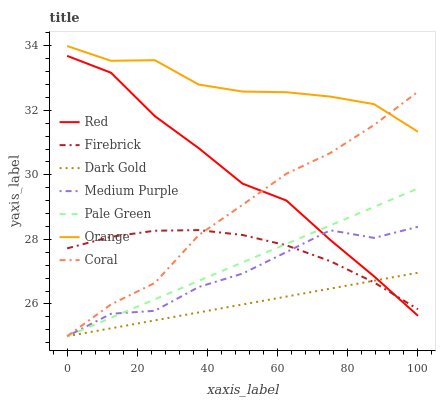Does Dark Gold have the minimum area under the curve?
Answer yes or no. Yes. Does Orange have the maximum area under the curve?
Answer yes or no. Yes. Does Firebrick have the minimum area under the curve?
Answer yes or no. No. Does Firebrick have the maximum area under the curve?
Answer yes or no. No. Is Dark Gold the smoothest?
Answer yes or no. Yes. Is Medium Purple the roughest?
Answer yes or no. Yes. Is Firebrick the smoothest?
Answer yes or no. No. Is Firebrick the roughest?
Answer yes or no. No. Does Firebrick have the lowest value?
Answer yes or no. No. Does Orange have the highest value?
Answer yes or no. Yes. Does Firebrick have the highest value?
Answer yes or no. No. Is Firebrick less than Orange?
Answer yes or no. Yes. Is Orange greater than Medium Purple?
Answer yes or no. Yes. Does Firebrick intersect Orange?
Answer yes or no. No. 